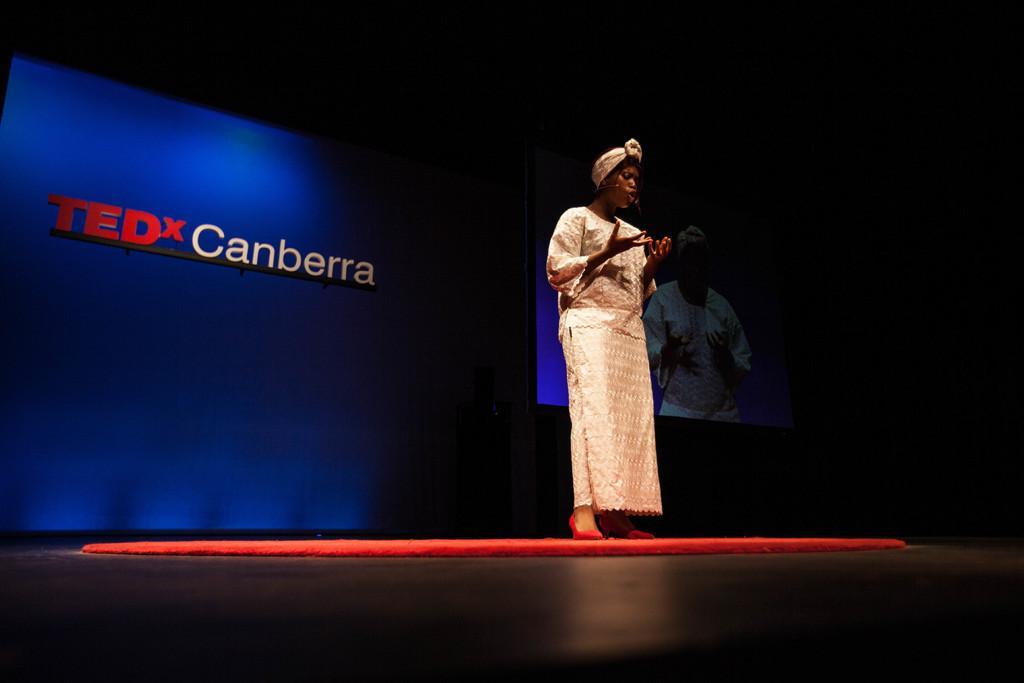Describe this image in one or two sentences. In the picture I can see a woman wearing cream color dress is standing and there is something written behind her and there is another image in the background. 